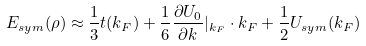<formula> <loc_0><loc_0><loc_500><loc_500>E _ { s y m } ( \rho ) \approx \frac { 1 } { 3 } t ( k _ { F } ) + \frac { 1 } { 6 } \frac { \partial U _ { 0 } } { \partial k } | _ { k _ { F } } \cdot k _ { F } + \frac { 1 } { 2 } U _ { s y m } ( k _ { F } )</formula> 